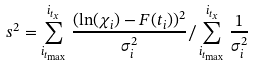Convert formula to latex. <formula><loc_0><loc_0><loc_500><loc_500>s ^ { 2 } = \sum _ { i _ { t _ { \max } } } ^ { i _ { t _ { x } } } \frac { ( \ln ( \chi _ { i } ) - F ( t _ { i } ) ) ^ { 2 } } { \sigma _ { i } ^ { 2 } } / \sum _ { i _ { t _ { \max } } } ^ { i _ { t _ { x } } } { \frac { 1 } { \sigma _ { i } ^ { 2 } } }</formula> 